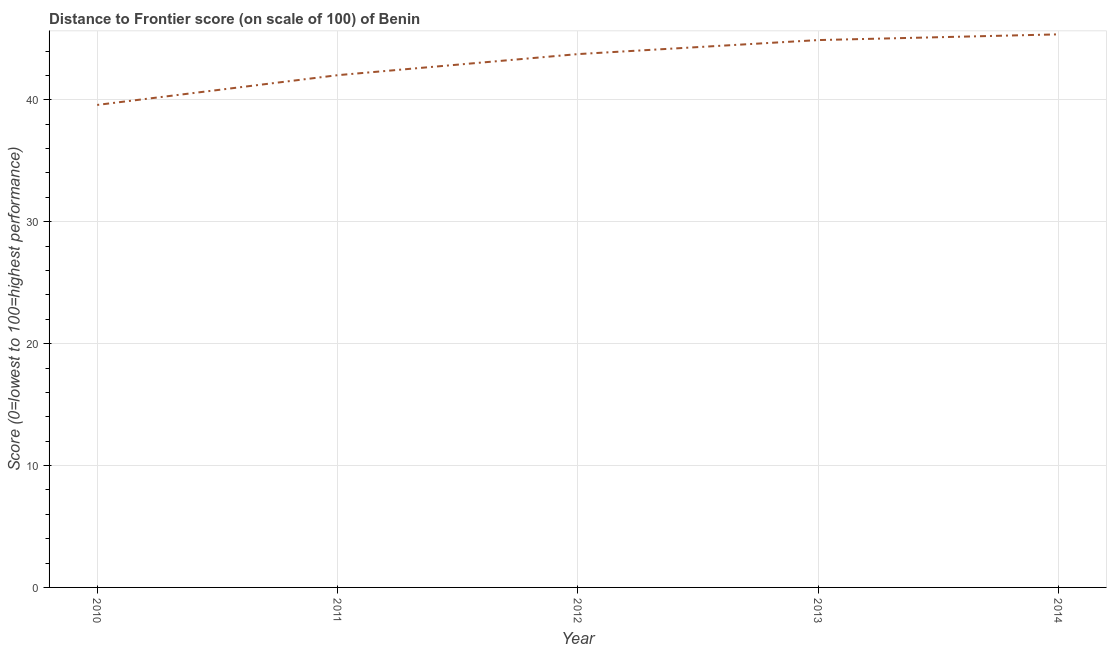What is the distance to frontier score in 2013?
Your answer should be compact. 44.9. Across all years, what is the maximum distance to frontier score?
Offer a very short reply. 45.37. Across all years, what is the minimum distance to frontier score?
Offer a terse response. 39.58. What is the sum of the distance to frontier score?
Keep it short and to the point. 215.62. What is the difference between the distance to frontier score in 2012 and 2013?
Provide a short and direct response. -1.15. What is the average distance to frontier score per year?
Make the answer very short. 43.12. What is the median distance to frontier score?
Offer a terse response. 43.75. In how many years, is the distance to frontier score greater than 16 ?
Ensure brevity in your answer.  5. Do a majority of the years between 2013 and 2012 (inclusive) have distance to frontier score greater than 40 ?
Your answer should be compact. No. What is the ratio of the distance to frontier score in 2010 to that in 2014?
Your answer should be very brief. 0.87. Is the distance to frontier score in 2011 less than that in 2012?
Offer a terse response. Yes. What is the difference between the highest and the second highest distance to frontier score?
Provide a short and direct response. 0.47. Is the sum of the distance to frontier score in 2011 and 2014 greater than the maximum distance to frontier score across all years?
Provide a short and direct response. Yes. What is the difference between the highest and the lowest distance to frontier score?
Provide a succinct answer. 5.79. How many lines are there?
Offer a terse response. 1. What is the difference between two consecutive major ticks on the Y-axis?
Give a very brief answer. 10. Does the graph contain grids?
Ensure brevity in your answer.  Yes. What is the title of the graph?
Make the answer very short. Distance to Frontier score (on scale of 100) of Benin. What is the label or title of the Y-axis?
Your answer should be compact. Score (0=lowest to 100=highest performance). What is the Score (0=lowest to 100=highest performance) of 2010?
Offer a terse response. 39.58. What is the Score (0=lowest to 100=highest performance) of 2011?
Your response must be concise. 42.02. What is the Score (0=lowest to 100=highest performance) in 2012?
Offer a very short reply. 43.75. What is the Score (0=lowest to 100=highest performance) in 2013?
Your answer should be very brief. 44.9. What is the Score (0=lowest to 100=highest performance) of 2014?
Make the answer very short. 45.37. What is the difference between the Score (0=lowest to 100=highest performance) in 2010 and 2011?
Offer a terse response. -2.44. What is the difference between the Score (0=lowest to 100=highest performance) in 2010 and 2012?
Offer a terse response. -4.17. What is the difference between the Score (0=lowest to 100=highest performance) in 2010 and 2013?
Your answer should be compact. -5.32. What is the difference between the Score (0=lowest to 100=highest performance) in 2010 and 2014?
Provide a succinct answer. -5.79. What is the difference between the Score (0=lowest to 100=highest performance) in 2011 and 2012?
Give a very brief answer. -1.73. What is the difference between the Score (0=lowest to 100=highest performance) in 2011 and 2013?
Your answer should be compact. -2.88. What is the difference between the Score (0=lowest to 100=highest performance) in 2011 and 2014?
Ensure brevity in your answer.  -3.35. What is the difference between the Score (0=lowest to 100=highest performance) in 2012 and 2013?
Offer a terse response. -1.15. What is the difference between the Score (0=lowest to 100=highest performance) in 2012 and 2014?
Ensure brevity in your answer.  -1.62. What is the difference between the Score (0=lowest to 100=highest performance) in 2013 and 2014?
Keep it short and to the point. -0.47. What is the ratio of the Score (0=lowest to 100=highest performance) in 2010 to that in 2011?
Provide a short and direct response. 0.94. What is the ratio of the Score (0=lowest to 100=highest performance) in 2010 to that in 2012?
Your answer should be compact. 0.91. What is the ratio of the Score (0=lowest to 100=highest performance) in 2010 to that in 2013?
Keep it short and to the point. 0.88. What is the ratio of the Score (0=lowest to 100=highest performance) in 2010 to that in 2014?
Give a very brief answer. 0.87. What is the ratio of the Score (0=lowest to 100=highest performance) in 2011 to that in 2012?
Ensure brevity in your answer.  0.96. What is the ratio of the Score (0=lowest to 100=highest performance) in 2011 to that in 2013?
Your answer should be very brief. 0.94. What is the ratio of the Score (0=lowest to 100=highest performance) in 2011 to that in 2014?
Your answer should be compact. 0.93. What is the ratio of the Score (0=lowest to 100=highest performance) in 2012 to that in 2013?
Provide a short and direct response. 0.97. What is the ratio of the Score (0=lowest to 100=highest performance) in 2013 to that in 2014?
Provide a succinct answer. 0.99. 